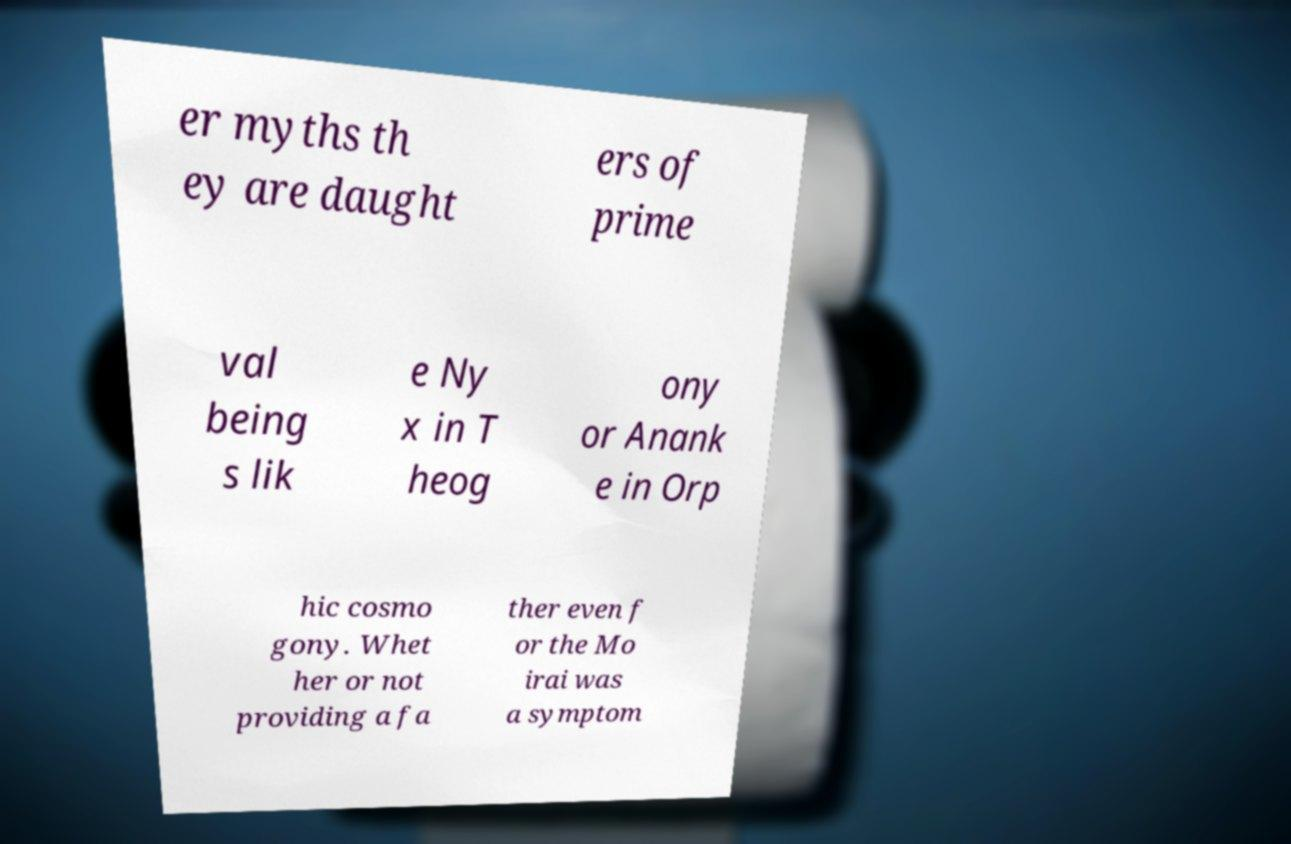Please read and relay the text visible in this image. What does it say? er myths th ey are daught ers of prime val being s lik e Ny x in T heog ony or Anank e in Orp hic cosmo gony. Whet her or not providing a fa ther even f or the Mo irai was a symptom 